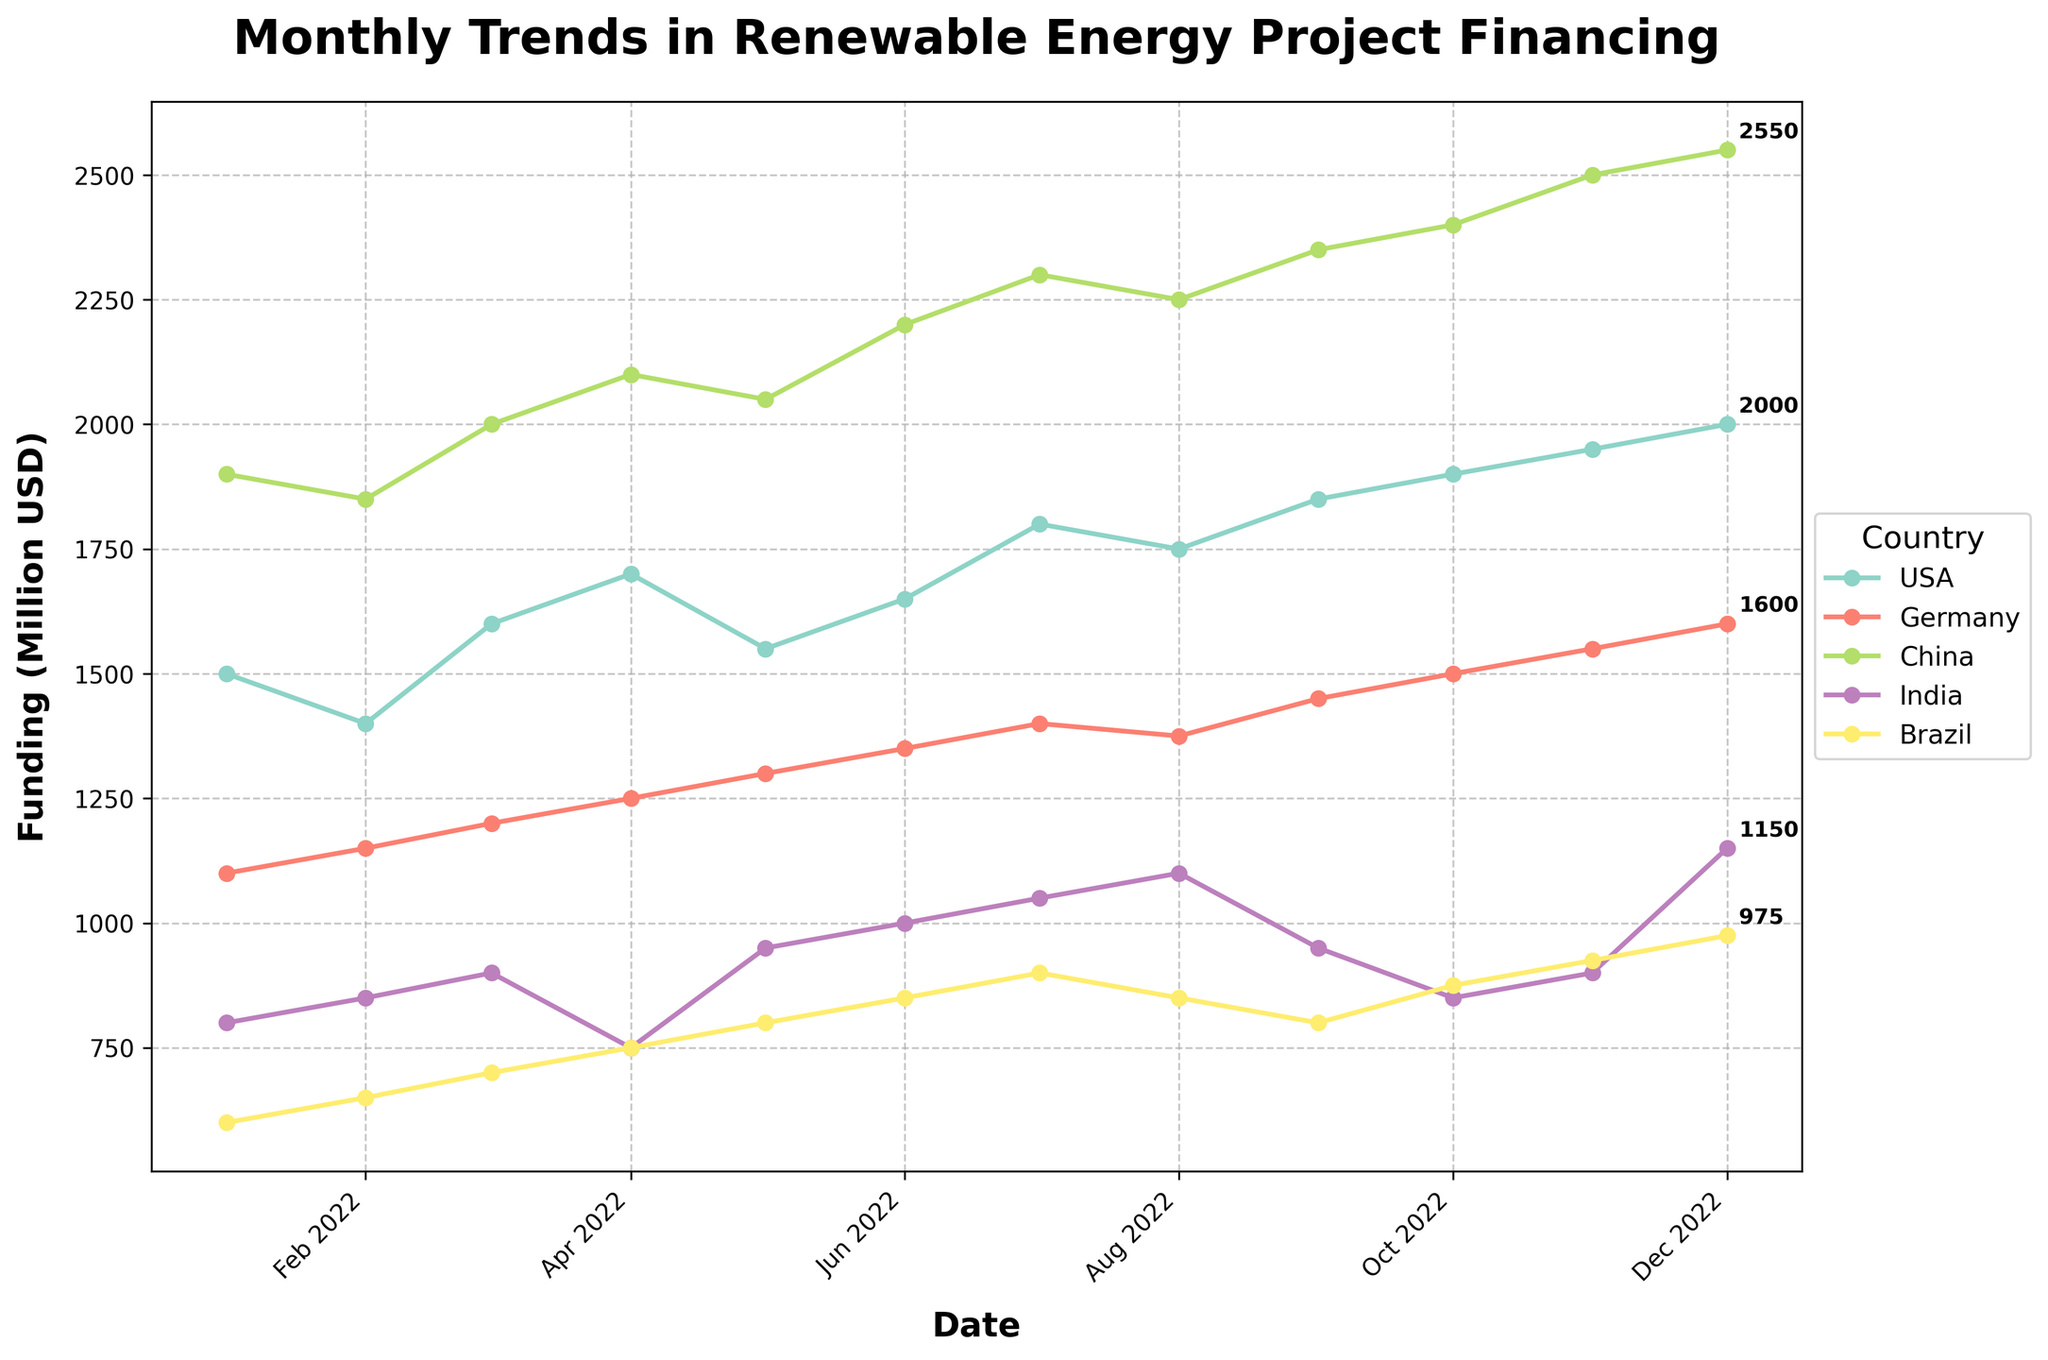What is the title of the figure? The title of the figure is usually found at the top and describes the main theme or subject of the visualization. In this case, it is clearly displayed at the top of the figure.
Answer: Monthly Trends in Renewable Energy Project Financing Which country has the highest renewable energy funding in December 2022? To identify the country with the highest funding in December 2022, look at the data points for this month across all countries and compare their vertical positions. The country with the highest point on the vertical axis represents the highest funding.
Answer: China How does the funding trend for India progress over the year? To describe the trend, trace the line corresponding to India from January to December. The vertical progression of the line indicates changes in funding. India shows fluctuation with a notable drop in funding around April and October, but an overall rise by December.
Answer: Mixed, with increases and decreases What is the difference in renewable energy funding between the USA and Germany in October 2022? Identify the data points for the USA and Germany in October 2022. Check the vertical axis values for both countries and subtract Germany's value from the USA's. USA: 1900, Germany: 1500; the difference is 1900 - 1500.
Answer: 400 Million USD Which country showed the most significant increase in funding from January to December 2022? Examine the plot to identify the lines for each country and observe how they trend from January to December. The country whose line shows the steepest upward slope indicates the most significant increase. Comparing the start and end points, China shows the largest rise.
Answer: China What pattern do you notice in Brazil's funding over the year? Look at the line corresponding to Brazil. By tracing its movement from January to December, note whether the line goes up, down, or remains stable. The line shows a general increase with some fluctuations.
Answer: Gradual increase with some fluctuations Did any country experience a decline in renewable energy funding during any part of the year? Analyze the lines representing each country month by month. A country experiences a decline if its line segment slopes downward. Both India (April and October) and Brazil (August and September) exhibit declines.
Answer: India and Brazil Which month shows the highest peak in renewable energy funding across all countries? Compare the peaks of all the lines month by month to identify the highest vertical point for any country. The highest peak corresponds to China in December.
Answer: December What is the overall trend in renewable energy funding across all countries over the year? Observe the general slopes of all the lines representing different countries. The majority of lines trend upwards, indicating a general increase in renewable energy funding throughout the year.
Answer: Increasing trend How does China's funding in September compare to Germany's funding in the same month? Locate the data points for China and Germany in September. Compare their values on the vertical axis. China's funding is significantly higher than Germany's in September.
Answer: China's funding is higher than Germany's 